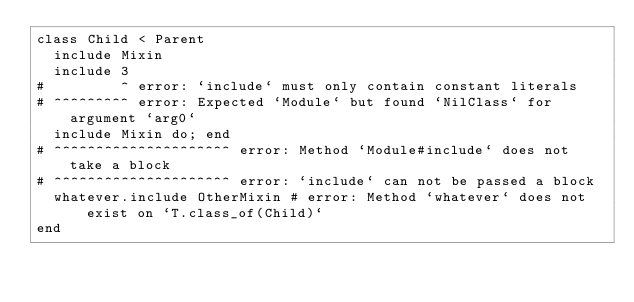<code> <loc_0><loc_0><loc_500><loc_500><_Ruby_>class Child < Parent
  include Mixin
  include 3
#         ^ error: `include` must only contain constant literals
# ^^^^^^^^^ error: Expected `Module` but found `NilClass` for argument `arg0`
  include Mixin do; end
# ^^^^^^^^^^^^^^^^^^^^^ error: Method `Module#include` does not take a block
# ^^^^^^^^^^^^^^^^^^^^^ error: `include` can not be passed a block
  whatever.include OtherMixin # error: Method `whatever` does not exist on `T.class_of(Child)`
end
</code> 